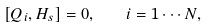Convert formula to latex. <formula><loc_0><loc_0><loc_500><loc_500>[ Q _ { i } , H _ { s } ] = 0 , \quad i = 1 \cdots N ,</formula> 